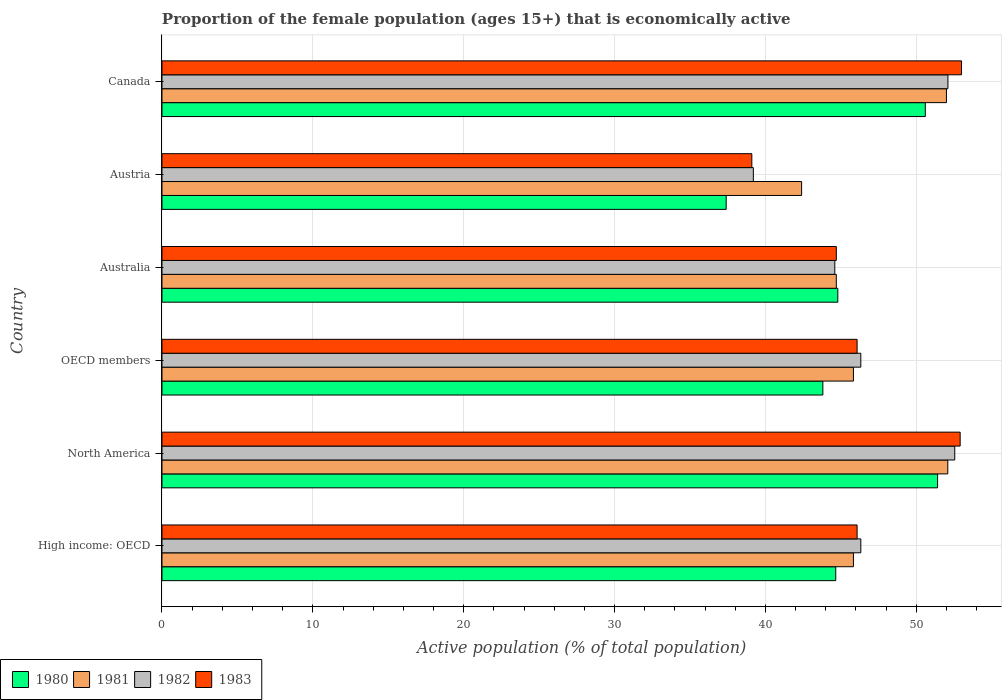How many different coloured bars are there?
Provide a succinct answer. 4. How many groups of bars are there?
Offer a very short reply. 6. Are the number of bars per tick equal to the number of legend labels?
Your response must be concise. Yes. How many bars are there on the 5th tick from the top?
Give a very brief answer. 4. In how many cases, is the number of bars for a given country not equal to the number of legend labels?
Keep it short and to the point. 0. What is the proportion of the female population that is economically active in 1981 in Austria?
Your response must be concise. 42.4. Across all countries, what is the maximum proportion of the female population that is economically active in 1980?
Make the answer very short. 51.41. Across all countries, what is the minimum proportion of the female population that is economically active in 1981?
Keep it short and to the point. 42.4. In which country was the proportion of the female population that is economically active in 1983 maximum?
Your answer should be very brief. Canada. In which country was the proportion of the female population that is economically active in 1981 minimum?
Provide a succinct answer. Austria. What is the total proportion of the female population that is economically active in 1980 in the graph?
Your response must be concise. 272.69. What is the difference between the proportion of the female population that is economically active in 1983 in High income: OECD and that in OECD members?
Keep it short and to the point. 0. What is the difference between the proportion of the female population that is economically active in 1980 in Australia and the proportion of the female population that is economically active in 1982 in High income: OECD?
Give a very brief answer. -1.52. What is the average proportion of the female population that is economically active in 1981 per country?
Provide a short and direct response. 47.14. What is the difference between the proportion of the female population that is economically active in 1983 and proportion of the female population that is economically active in 1981 in High income: OECD?
Provide a succinct answer. 0.24. In how many countries, is the proportion of the female population that is economically active in 1980 greater than 38 %?
Give a very brief answer. 5. What is the ratio of the proportion of the female population that is economically active in 1982 in High income: OECD to that in OECD members?
Keep it short and to the point. 1. Is the proportion of the female population that is economically active in 1983 in High income: OECD less than that in OECD members?
Give a very brief answer. No. What is the difference between the highest and the second highest proportion of the female population that is economically active in 1980?
Offer a very short reply. 0.81. What is the difference between the highest and the lowest proportion of the female population that is economically active in 1983?
Offer a very short reply. 13.9. In how many countries, is the proportion of the female population that is economically active in 1980 greater than the average proportion of the female population that is economically active in 1980 taken over all countries?
Keep it short and to the point. 2. Is the sum of the proportion of the female population that is economically active in 1983 in North America and OECD members greater than the maximum proportion of the female population that is economically active in 1982 across all countries?
Offer a very short reply. Yes. Is it the case that in every country, the sum of the proportion of the female population that is economically active in 1980 and proportion of the female population that is economically active in 1983 is greater than the sum of proportion of the female population that is economically active in 1981 and proportion of the female population that is economically active in 1982?
Your answer should be very brief. No. Is it the case that in every country, the sum of the proportion of the female population that is economically active in 1982 and proportion of the female population that is economically active in 1980 is greater than the proportion of the female population that is economically active in 1983?
Make the answer very short. Yes. Are all the bars in the graph horizontal?
Your answer should be compact. Yes. How many countries are there in the graph?
Ensure brevity in your answer.  6. What is the difference between two consecutive major ticks on the X-axis?
Your answer should be very brief. 10. Where does the legend appear in the graph?
Make the answer very short. Bottom left. How many legend labels are there?
Your answer should be compact. 4. What is the title of the graph?
Provide a succinct answer. Proportion of the female population (ages 15+) that is economically active. Does "2003" appear as one of the legend labels in the graph?
Ensure brevity in your answer.  No. What is the label or title of the X-axis?
Your response must be concise. Active population (% of total population). What is the Active population (% of total population) in 1980 in High income: OECD?
Provide a succinct answer. 44.66. What is the Active population (% of total population) of 1981 in High income: OECD?
Offer a very short reply. 45.84. What is the Active population (% of total population) in 1982 in High income: OECD?
Provide a short and direct response. 46.32. What is the Active population (% of total population) in 1983 in High income: OECD?
Keep it short and to the point. 46.08. What is the Active population (% of total population) in 1980 in North America?
Your answer should be compact. 51.41. What is the Active population (% of total population) in 1981 in North America?
Your answer should be compact. 52.09. What is the Active population (% of total population) in 1982 in North America?
Give a very brief answer. 52.55. What is the Active population (% of total population) of 1983 in North America?
Your answer should be very brief. 52.91. What is the Active population (% of total population) in 1980 in OECD members?
Your answer should be very brief. 43.81. What is the Active population (% of total population) in 1981 in OECD members?
Your answer should be very brief. 45.84. What is the Active population (% of total population) in 1982 in OECD members?
Provide a short and direct response. 46.32. What is the Active population (% of total population) of 1983 in OECD members?
Your response must be concise. 46.08. What is the Active population (% of total population) in 1980 in Australia?
Provide a succinct answer. 44.8. What is the Active population (% of total population) in 1981 in Australia?
Give a very brief answer. 44.7. What is the Active population (% of total population) in 1982 in Australia?
Your answer should be very brief. 44.6. What is the Active population (% of total population) in 1983 in Australia?
Your answer should be very brief. 44.7. What is the Active population (% of total population) in 1980 in Austria?
Your response must be concise. 37.4. What is the Active population (% of total population) of 1981 in Austria?
Ensure brevity in your answer.  42.4. What is the Active population (% of total population) in 1982 in Austria?
Make the answer very short. 39.2. What is the Active population (% of total population) in 1983 in Austria?
Your response must be concise. 39.1. What is the Active population (% of total population) of 1980 in Canada?
Give a very brief answer. 50.6. What is the Active population (% of total population) of 1982 in Canada?
Provide a short and direct response. 52.1. Across all countries, what is the maximum Active population (% of total population) in 1980?
Ensure brevity in your answer.  51.41. Across all countries, what is the maximum Active population (% of total population) of 1981?
Your response must be concise. 52.09. Across all countries, what is the maximum Active population (% of total population) of 1982?
Keep it short and to the point. 52.55. Across all countries, what is the minimum Active population (% of total population) in 1980?
Offer a very short reply. 37.4. Across all countries, what is the minimum Active population (% of total population) of 1981?
Make the answer very short. 42.4. Across all countries, what is the minimum Active population (% of total population) in 1982?
Your answer should be very brief. 39.2. Across all countries, what is the minimum Active population (% of total population) of 1983?
Provide a short and direct response. 39.1. What is the total Active population (% of total population) in 1980 in the graph?
Your response must be concise. 272.69. What is the total Active population (% of total population) of 1981 in the graph?
Provide a succinct answer. 282.86. What is the total Active population (% of total population) of 1982 in the graph?
Offer a very short reply. 281.1. What is the total Active population (% of total population) in 1983 in the graph?
Your response must be concise. 281.87. What is the difference between the Active population (% of total population) of 1980 in High income: OECD and that in North America?
Give a very brief answer. -6.75. What is the difference between the Active population (% of total population) of 1981 in High income: OECD and that in North America?
Your answer should be compact. -6.25. What is the difference between the Active population (% of total population) in 1982 in High income: OECD and that in North America?
Keep it short and to the point. -6.23. What is the difference between the Active population (% of total population) in 1983 in High income: OECD and that in North America?
Provide a succinct answer. -6.83. What is the difference between the Active population (% of total population) of 1980 in High income: OECD and that in OECD members?
Your answer should be compact. 0.85. What is the difference between the Active population (% of total population) in 1981 in High income: OECD and that in OECD members?
Your answer should be very brief. 0. What is the difference between the Active population (% of total population) in 1980 in High income: OECD and that in Australia?
Make the answer very short. -0.14. What is the difference between the Active population (% of total population) in 1981 in High income: OECD and that in Australia?
Offer a very short reply. 1.14. What is the difference between the Active population (% of total population) in 1982 in High income: OECD and that in Australia?
Make the answer very short. 1.72. What is the difference between the Active population (% of total population) of 1983 in High income: OECD and that in Australia?
Offer a terse response. 1.38. What is the difference between the Active population (% of total population) in 1980 in High income: OECD and that in Austria?
Provide a succinct answer. 7.26. What is the difference between the Active population (% of total population) of 1981 in High income: OECD and that in Austria?
Your answer should be very brief. 3.44. What is the difference between the Active population (% of total population) in 1982 in High income: OECD and that in Austria?
Keep it short and to the point. 7.12. What is the difference between the Active population (% of total population) in 1983 in High income: OECD and that in Austria?
Ensure brevity in your answer.  6.98. What is the difference between the Active population (% of total population) of 1980 in High income: OECD and that in Canada?
Offer a terse response. -5.94. What is the difference between the Active population (% of total population) of 1981 in High income: OECD and that in Canada?
Provide a succinct answer. -6.16. What is the difference between the Active population (% of total population) in 1982 in High income: OECD and that in Canada?
Make the answer very short. -5.78. What is the difference between the Active population (% of total population) in 1983 in High income: OECD and that in Canada?
Provide a short and direct response. -6.92. What is the difference between the Active population (% of total population) in 1980 in North America and that in OECD members?
Your answer should be very brief. 7.61. What is the difference between the Active population (% of total population) in 1981 in North America and that in OECD members?
Provide a succinct answer. 6.25. What is the difference between the Active population (% of total population) in 1982 in North America and that in OECD members?
Provide a short and direct response. 6.23. What is the difference between the Active population (% of total population) in 1983 in North America and that in OECD members?
Your answer should be compact. 6.83. What is the difference between the Active population (% of total population) of 1980 in North America and that in Australia?
Offer a very short reply. 6.61. What is the difference between the Active population (% of total population) in 1981 in North America and that in Australia?
Ensure brevity in your answer.  7.39. What is the difference between the Active population (% of total population) in 1982 in North America and that in Australia?
Make the answer very short. 7.95. What is the difference between the Active population (% of total population) of 1983 in North America and that in Australia?
Ensure brevity in your answer.  8.21. What is the difference between the Active population (% of total population) of 1980 in North America and that in Austria?
Offer a very short reply. 14.01. What is the difference between the Active population (% of total population) in 1981 in North America and that in Austria?
Offer a very short reply. 9.69. What is the difference between the Active population (% of total population) in 1982 in North America and that in Austria?
Make the answer very short. 13.35. What is the difference between the Active population (% of total population) of 1983 in North America and that in Austria?
Your answer should be very brief. 13.81. What is the difference between the Active population (% of total population) of 1980 in North America and that in Canada?
Keep it short and to the point. 0.81. What is the difference between the Active population (% of total population) in 1981 in North America and that in Canada?
Make the answer very short. 0.09. What is the difference between the Active population (% of total population) of 1982 in North America and that in Canada?
Make the answer very short. 0.45. What is the difference between the Active population (% of total population) of 1983 in North America and that in Canada?
Make the answer very short. -0.09. What is the difference between the Active population (% of total population) of 1980 in OECD members and that in Australia?
Offer a terse response. -0.99. What is the difference between the Active population (% of total population) of 1981 in OECD members and that in Australia?
Provide a short and direct response. 1.14. What is the difference between the Active population (% of total population) in 1982 in OECD members and that in Australia?
Provide a succinct answer. 1.72. What is the difference between the Active population (% of total population) in 1983 in OECD members and that in Australia?
Offer a very short reply. 1.38. What is the difference between the Active population (% of total population) of 1980 in OECD members and that in Austria?
Offer a terse response. 6.41. What is the difference between the Active population (% of total population) of 1981 in OECD members and that in Austria?
Offer a very short reply. 3.44. What is the difference between the Active population (% of total population) of 1982 in OECD members and that in Austria?
Your answer should be very brief. 7.12. What is the difference between the Active population (% of total population) in 1983 in OECD members and that in Austria?
Make the answer very short. 6.98. What is the difference between the Active population (% of total population) in 1980 in OECD members and that in Canada?
Provide a succinct answer. -6.79. What is the difference between the Active population (% of total population) in 1981 in OECD members and that in Canada?
Provide a short and direct response. -6.16. What is the difference between the Active population (% of total population) of 1982 in OECD members and that in Canada?
Your answer should be very brief. -5.78. What is the difference between the Active population (% of total population) in 1983 in OECD members and that in Canada?
Keep it short and to the point. -6.92. What is the difference between the Active population (% of total population) of 1980 in Australia and that in Canada?
Your answer should be very brief. -5.8. What is the difference between the Active population (% of total population) of 1981 in Australia and that in Canada?
Your response must be concise. -7.3. What is the difference between the Active population (% of total population) of 1982 in Australia and that in Canada?
Your response must be concise. -7.5. What is the difference between the Active population (% of total population) in 1983 in Australia and that in Canada?
Ensure brevity in your answer.  -8.3. What is the difference between the Active population (% of total population) of 1980 in Austria and that in Canada?
Provide a short and direct response. -13.2. What is the difference between the Active population (% of total population) of 1982 in Austria and that in Canada?
Offer a terse response. -12.9. What is the difference between the Active population (% of total population) of 1980 in High income: OECD and the Active population (% of total population) of 1981 in North America?
Offer a very short reply. -7.43. What is the difference between the Active population (% of total population) in 1980 in High income: OECD and the Active population (% of total population) in 1982 in North America?
Offer a terse response. -7.89. What is the difference between the Active population (% of total population) of 1980 in High income: OECD and the Active population (% of total population) of 1983 in North America?
Give a very brief answer. -8.25. What is the difference between the Active population (% of total population) of 1981 in High income: OECD and the Active population (% of total population) of 1982 in North America?
Offer a very short reply. -6.72. What is the difference between the Active population (% of total population) in 1981 in High income: OECD and the Active population (% of total population) in 1983 in North America?
Offer a terse response. -7.07. What is the difference between the Active population (% of total population) in 1982 in High income: OECD and the Active population (% of total population) in 1983 in North America?
Provide a succinct answer. -6.58. What is the difference between the Active population (% of total population) in 1980 in High income: OECD and the Active population (% of total population) in 1981 in OECD members?
Ensure brevity in your answer.  -1.17. What is the difference between the Active population (% of total population) in 1980 in High income: OECD and the Active population (% of total population) in 1982 in OECD members?
Provide a short and direct response. -1.66. What is the difference between the Active population (% of total population) in 1980 in High income: OECD and the Active population (% of total population) in 1983 in OECD members?
Your response must be concise. -1.42. What is the difference between the Active population (% of total population) in 1981 in High income: OECD and the Active population (% of total population) in 1982 in OECD members?
Ensure brevity in your answer.  -0.49. What is the difference between the Active population (% of total population) of 1981 in High income: OECD and the Active population (% of total population) of 1983 in OECD members?
Keep it short and to the point. -0.24. What is the difference between the Active population (% of total population) in 1982 in High income: OECD and the Active population (% of total population) in 1983 in OECD members?
Your answer should be very brief. 0.25. What is the difference between the Active population (% of total population) of 1980 in High income: OECD and the Active population (% of total population) of 1981 in Australia?
Your response must be concise. -0.04. What is the difference between the Active population (% of total population) of 1980 in High income: OECD and the Active population (% of total population) of 1982 in Australia?
Offer a very short reply. 0.06. What is the difference between the Active population (% of total population) of 1980 in High income: OECD and the Active population (% of total population) of 1983 in Australia?
Provide a short and direct response. -0.04. What is the difference between the Active population (% of total population) of 1981 in High income: OECD and the Active population (% of total population) of 1982 in Australia?
Give a very brief answer. 1.24. What is the difference between the Active population (% of total population) of 1981 in High income: OECD and the Active population (% of total population) of 1983 in Australia?
Ensure brevity in your answer.  1.14. What is the difference between the Active population (% of total population) in 1982 in High income: OECD and the Active population (% of total population) in 1983 in Australia?
Give a very brief answer. 1.62. What is the difference between the Active population (% of total population) in 1980 in High income: OECD and the Active population (% of total population) in 1981 in Austria?
Make the answer very short. 2.26. What is the difference between the Active population (% of total population) of 1980 in High income: OECD and the Active population (% of total population) of 1982 in Austria?
Offer a very short reply. 5.46. What is the difference between the Active population (% of total population) of 1980 in High income: OECD and the Active population (% of total population) of 1983 in Austria?
Make the answer very short. 5.56. What is the difference between the Active population (% of total population) in 1981 in High income: OECD and the Active population (% of total population) in 1982 in Austria?
Provide a succinct answer. 6.64. What is the difference between the Active population (% of total population) of 1981 in High income: OECD and the Active population (% of total population) of 1983 in Austria?
Ensure brevity in your answer.  6.74. What is the difference between the Active population (% of total population) in 1982 in High income: OECD and the Active population (% of total population) in 1983 in Austria?
Your response must be concise. 7.22. What is the difference between the Active population (% of total population) in 1980 in High income: OECD and the Active population (% of total population) in 1981 in Canada?
Your response must be concise. -7.34. What is the difference between the Active population (% of total population) of 1980 in High income: OECD and the Active population (% of total population) of 1982 in Canada?
Your answer should be very brief. -7.44. What is the difference between the Active population (% of total population) in 1980 in High income: OECD and the Active population (% of total population) in 1983 in Canada?
Provide a succinct answer. -8.34. What is the difference between the Active population (% of total population) in 1981 in High income: OECD and the Active population (% of total population) in 1982 in Canada?
Ensure brevity in your answer.  -6.26. What is the difference between the Active population (% of total population) in 1981 in High income: OECD and the Active population (% of total population) in 1983 in Canada?
Provide a succinct answer. -7.16. What is the difference between the Active population (% of total population) in 1982 in High income: OECD and the Active population (% of total population) in 1983 in Canada?
Give a very brief answer. -6.68. What is the difference between the Active population (% of total population) of 1980 in North America and the Active population (% of total population) of 1981 in OECD members?
Ensure brevity in your answer.  5.58. What is the difference between the Active population (% of total population) in 1980 in North America and the Active population (% of total population) in 1982 in OECD members?
Give a very brief answer. 5.09. What is the difference between the Active population (% of total population) in 1980 in North America and the Active population (% of total population) in 1983 in OECD members?
Your answer should be very brief. 5.34. What is the difference between the Active population (% of total population) of 1981 in North America and the Active population (% of total population) of 1982 in OECD members?
Offer a very short reply. 5.77. What is the difference between the Active population (% of total population) in 1981 in North America and the Active population (% of total population) in 1983 in OECD members?
Your response must be concise. 6.01. What is the difference between the Active population (% of total population) in 1982 in North America and the Active population (% of total population) in 1983 in OECD members?
Keep it short and to the point. 6.47. What is the difference between the Active population (% of total population) in 1980 in North America and the Active population (% of total population) in 1981 in Australia?
Your answer should be compact. 6.71. What is the difference between the Active population (% of total population) of 1980 in North America and the Active population (% of total population) of 1982 in Australia?
Offer a terse response. 6.81. What is the difference between the Active population (% of total population) in 1980 in North America and the Active population (% of total population) in 1983 in Australia?
Your answer should be compact. 6.71. What is the difference between the Active population (% of total population) of 1981 in North America and the Active population (% of total population) of 1982 in Australia?
Your response must be concise. 7.49. What is the difference between the Active population (% of total population) of 1981 in North America and the Active population (% of total population) of 1983 in Australia?
Offer a terse response. 7.39. What is the difference between the Active population (% of total population) in 1982 in North America and the Active population (% of total population) in 1983 in Australia?
Give a very brief answer. 7.85. What is the difference between the Active population (% of total population) in 1980 in North America and the Active population (% of total population) in 1981 in Austria?
Offer a very short reply. 9.01. What is the difference between the Active population (% of total population) of 1980 in North America and the Active population (% of total population) of 1982 in Austria?
Give a very brief answer. 12.21. What is the difference between the Active population (% of total population) in 1980 in North America and the Active population (% of total population) in 1983 in Austria?
Ensure brevity in your answer.  12.31. What is the difference between the Active population (% of total population) in 1981 in North America and the Active population (% of total population) in 1982 in Austria?
Provide a short and direct response. 12.89. What is the difference between the Active population (% of total population) of 1981 in North America and the Active population (% of total population) of 1983 in Austria?
Keep it short and to the point. 12.99. What is the difference between the Active population (% of total population) in 1982 in North America and the Active population (% of total population) in 1983 in Austria?
Provide a short and direct response. 13.45. What is the difference between the Active population (% of total population) of 1980 in North America and the Active population (% of total population) of 1981 in Canada?
Give a very brief answer. -0.59. What is the difference between the Active population (% of total population) of 1980 in North America and the Active population (% of total population) of 1982 in Canada?
Your response must be concise. -0.69. What is the difference between the Active population (% of total population) of 1980 in North America and the Active population (% of total population) of 1983 in Canada?
Your response must be concise. -1.59. What is the difference between the Active population (% of total population) of 1981 in North America and the Active population (% of total population) of 1982 in Canada?
Offer a very short reply. -0.01. What is the difference between the Active population (% of total population) in 1981 in North America and the Active population (% of total population) in 1983 in Canada?
Offer a terse response. -0.91. What is the difference between the Active population (% of total population) in 1982 in North America and the Active population (% of total population) in 1983 in Canada?
Your answer should be very brief. -0.45. What is the difference between the Active population (% of total population) of 1980 in OECD members and the Active population (% of total population) of 1981 in Australia?
Ensure brevity in your answer.  -0.89. What is the difference between the Active population (% of total population) in 1980 in OECD members and the Active population (% of total population) in 1982 in Australia?
Provide a succinct answer. -0.79. What is the difference between the Active population (% of total population) in 1980 in OECD members and the Active population (% of total population) in 1983 in Australia?
Give a very brief answer. -0.89. What is the difference between the Active population (% of total population) of 1981 in OECD members and the Active population (% of total population) of 1982 in Australia?
Provide a succinct answer. 1.24. What is the difference between the Active population (% of total population) in 1981 in OECD members and the Active population (% of total population) in 1983 in Australia?
Offer a terse response. 1.14. What is the difference between the Active population (% of total population) of 1982 in OECD members and the Active population (% of total population) of 1983 in Australia?
Your answer should be very brief. 1.62. What is the difference between the Active population (% of total population) in 1980 in OECD members and the Active population (% of total population) in 1981 in Austria?
Keep it short and to the point. 1.41. What is the difference between the Active population (% of total population) of 1980 in OECD members and the Active population (% of total population) of 1982 in Austria?
Ensure brevity in your answer.  4.61. What is the difference between the Active population (% of total population) in 1980 in OECD members and the Active population (% of total population) in 1983 in Austria?
Provide a short and direct response. 4.71. What is the difference between the Active population (% of total population) in 1981 in OECD members and the Active population (% of total population) in 1982 in Austria?
Your response must be concise. 6.64. What is the difference between the Active population (% of total population) in 1981 in OECD members and the Active population (% of total population) in 1983 in Austria?
Make the answer very short. 6.74. What is the difference between the Active population (% of total population) of 1982 in OECD members and the Active population (% of total population) of 1983 in Austria?
Your answer should be very brief. 7.22. What is the difference between the Active population (% of total population) in 1980 in OECD members and the Active population (% of total population) in 1981 in Canada?
Give a very brief answer. -8.19. What is the difference between the Active population (% of total population) in 1980 in OECD members and the Active population (% of total population) in 1982 in Canada?
Keep it short and to the point. -8.29. What is the difference between the Active population (% of total population) in 1980 in OECD members and the Active population (% of total population) in 1983 in Canada?
Your answer should be compact. -9.19. What is the difference between the Active population (% of total population) of 1981 in OECD members and the Active population (% of total population) of 1982 in Canada?
Your response must be concise. -6.26. What is the difference between the Active population (% of total population) in 1981 in OECD members and the Active population (% of total population) in 1983 in Canada?
Offer a terse response. -7.16. What is the difference between the Active population (% of total population) in 1982 in OECD members and the Active population (% of total population) in 1983 in Canada?
Give a very brief answer. -6.68. What is the difference between the Active population (% of total population) in 1980 in Australia and the Active population (% of total population) in 1983 in Austria?
Ensure brevity in your answer.  5.7. What is the difference between the Active population (% of total population) of 1981 in Australia and the Active population (% of total population) of 1983 in Austria?
Offer a terse response. 5.6. What is the difference between the Active population (% of total population) of 1982 in Australia and the Active population (% of total population) of 1983 in Austria?
Ensure brevity in your answer.  5.5. What is the difference between the Active population (% of total population) in 1981 in Australia and the Active population (% of total population) in 1982 in Canada?
Provide a succinct answer. -7.4. What is the difference between the Active population (% of total population) of 1981 in Australia and the Active population (% of total population) of 1983 in Canada?
Your response must be concise. -8.3. What is the difference between the Active population (% of total population) in 1982 in Australia and the Active population (% of total population) in 1983 in Canada?
Ensure brevity in your answer.  -8.4. What is the difference between the Active population (% of total population) in 1980 in Austria and the Active population (% of total population) in 1981 in Canada?
Offer a terse response. -14.6. What is the difference between the Active population (% of total population) of 1980 in Austria and the Active population (% of total population) of 1982 in Canada?
Give a very brief answer. -14.7. What is the difference between the Active population (% of total population) in 1980 in Austria and the Active population (% of total population) in 1983 in Canada?
Make the answer very short. -15.6. What is the difference between the Active population (% of total population) in 1981 in Austria and the Active population (% of total population) in 1982 in Canada?
Provide a succinct answer. -9.7. What is the difference between the Active population (% of total population) of 1981 in Austria and the Active population (% of total population) of 1983 in Canada?
Make the answer very short. -10.6. What is the average Active population (% of total population) in 1980 per country?
Give a very brief answer. 45.45. What is the average Active population (% of total population) in 1981 per country?
Provide a short and direct response. 47.14. What is the average Active population (% of total population) in 1982 per country?
Your response must be concise. 46.85. What is the average Active population (% of total population) of 1983 per country?
Keep it short and to the point. 46.98. What is the difference between the Active population (% of total population) of 1980 and Active population (% of total population) of 1981 in High income: OECD?
Your answer should be compact. -1.17. What is the difference between the Active population (% of total population) in 1980 and Active population (% of total population) in 1982 in High income: OECD?
Provide a succinct answer. -1.66. What is the difference between the Active population (% of total population) in 1980 and Active population (% of total population) in 1983 in High income: OECD?
Offer a terse response. -1.42. What is the difference between the Active population (% of total population) in 1981 and Active population (% of total population) in 1982 in High income: OECD?
Provide a succinct answer. -0.49. What is the difference between the Active population (% of total population) in 1981 and Active population (% of total population) in 1983 in High income: OECD?
Give a very brief answer. -0.24. What is the difference between the Active population (% of total population) of 1982 and Active population (% of total population) of 1983 in High income: OECD?
Ensure brevity in your answer.  0.25. What is the difference between the Active population (% of total population) of 1980 and Active population (% of total population) of 1981 in North America?
Your answer should be very brief. -0.68. What is the difference between the Active population (% of total population) of 1980 and Active population (% of total population) of 1982 in North America?
Your response must be concise. -1.14. What is the difference between the Active population (% of total population) of 1980 and Active population (% of total population) of 1983 in North America?
Your answer should be very brief. -1.5. What is the difference between the Active population (% of total population) of 1981 and Active population (% of total population) of 1982 in North America?
Your answer should be compact. -0.46. What is the difference between the Active population (% of total population) of 1981 and Active population (% of total population) of 1983 in North America?
Offer a terse response. -0.82. What is the difference between the Active population (% of total population) of 1982 and Active population (% of total population) of 1983 in North America?
Your answer should be very brief. -0.36. What is the difference between the Active population (% of total population) in 1980 and Active population (% of total population) in 1981 in OECD members?
Ensure brevity in your answer.  -2.03. What is the difference between the Active population (% of total population) of 1980 and Active population (% of total population) of 1982 in OECD members?
Offer a very short reply. -2.52. What is the difference between the Active population (% of total population) of 1980 and Active population (% of total population) of 1983 in OECD members?
Give a very brief answer. -2.27. What is the difference between the Active population (% of total population) of 1981 and Active population (% of total population) of 1982 in OECD members?
Provide a short and direct response. -0.49. What is the difference between the Active population (% of total population) in 1981 and Active population (% of total population) in 1983 in OECD members?
Give a very brief answer. -0.24. What is the difference between the Active population (% of total population) of 1982 and Active population (% of total population) of 1983 in OECD members?
Make the answer very short. 0.25. What is the difference between the Active population (% of total population) in 1980 and Active population (% of total population) in 1983 in Australia?
Offer a terse response. 0.1. What is the difference between the Active population (% of total population) of 1981 and Active population (% of total population) of 1982 in Australia?
Make the answer very short. 0.1. What is the difference between the Active population (% of total population) in 1980 and Active population (% of total population) in 1981 in Austria?
Offer a very short reply. -5. What is the difference between the Active population (% of total population) of 1980 and Active population (% of total population) of 1982 in Austria?
Provide a succinct answer. -1.8. What is the difference between the Active population (% of total population) in 1980 and Active population (% of total population) in 1983 in Austria?
Your answer should be compact. -1.7. What is the difference between the Active population (% of total population) of 1981 and Active population (% of total population) of 1983 in Austria?
Provide a short and direct response. 3.3. What is the difference between the Active population (% of total population) of 1982 and Active population (% of total population) of 1983 in Austria?
Ensure brevity in your answer.  0.1. What is the difference between the Active population (% of total population) in 1980 and Active population (% of total population) in 1983 in Canada?
Provide a succinct answer. -2.4. What is the difference between the Active population (% of total population) of 1981 and Active population (% of total population) of 1982 in Canada?
Provide a succinct answer. -0.1. What is the difference between the Active population (% of total population) in 1981 and Active population (% of total population) in 1983 in Canada?
Give a very brief answer. -1. What is the ratio of the Active population (% of total population) in 1980 in High income: OECD to that in North America?
Offer a terse response. 0.87. What is the ratio of the Active population (% of total population) in 1981 in High income: OECD to that in North America?
Make the answer very short. 0.88. What is the ratio of the Active population (% of total population) of 1982 in High income: OECD to that in North America?
Give a very brief answer. 0.88. What is the ratio of the Active population (% of total population) of 1983 in High income: OECD to that in North America?
Your answer should be very brief. 0.87. What is the ratio of the Active population (% of total population) in 1980 in High income: OECD to that in OECD members?
Offer a very short reply. 1.02. What is the ratio of the Active population (% of total population) in 1981 in High income: OECD to that in OECD members?
Offer a very short reply. 1. What is the ratio of the Active population (% of total population) in 1982 in High income: OECD to that in OECD members?
Provide a succinct answer. 1. What is the ratio of the Active population (% of total population) in 1981 in High income: OECD to that in Australia?
Offer a terse response. 1.03. What is the ratio of the Active population (% of total population) in 1982 in High income: OECD to that in Australia?
Provide a short and direct response. 1.04. What is the ratio of the Active population (% of total population) of 1983 in High income: OECD to that in Australia?
Your answer should be very brief. 1.03. What is the ratio of the Active population (% of total population) of 1980 in High income: OECD to that in Austria?
Give a very brief answer. 1.19. What is the ratio of the Active population (% of total population) in 1981 in High income: OECD to that in Austria?
Offer a very short reply. 1.08. What is the ratio of the Active population (% of total population) in 1982 in High income: OECD to that in Austria?
Make the answer very short. 1.18. What is the ratio of the Active population (% of total population) of 1983 in High income: OECD to that in Austria?
Provide a succinct answer. 1.18. What is the ratio of the Active population (% of total population) in 1980 in High income: OECD to that in Canada?
Your answer should be compact. 0.88. What is the ratio of the Active population (% of total population) in 1981 in High income: OECD to that in Canada?
Your answer should be very brief. 0.88. What is the ratio of the Active population (% of total population) in 1982 in High income: OECD to that in Canada?
Ensure brevity in your answer.  0.89. What is the ratio of the Active population (% of total population) in 1983 in High income: OECD to that in Canada?
Your answer should be compact. 0.87. What is the ratio of the Active population (% of total population) of 1980 in North America to that in OECD members?
Your answer should be very brief. 1.17. What is the ratio of the Active population (% of total population) of 1981 in North America to that in OECD members?
Provide a short and direct response. 1.14. What is the ratio of the Active population (% of total population) in 1982 in North America to that in OECD members?
Make the answer very short. 1.13. What is the ratio of the Active population (% of total population) in 1983 in North America to that in OECD members?
Provide a short and direct response. 1.15. What is the ratio of the Active population (% of total population) in 1980 in North America to that in Australia?
Provide a succinct answer. 1.15. What is the ratio of the Active population (% of total population) of 1981 in North America to that in Australia?
Your response must be concise. 1.17. What is the ratio of the Active population (% of total population) in 1982 in North America to that in Australia?
Offer a terse response. 1.18. What is the ratio of the Active population (% of total population) in 1983 in North America to that in Australia?
Make the answer very short. 1.18. What is the ratio of the Active population (% of total population) of 1980 in North America to that in Austria?
Your response must be concise. 1.37. What is the ratio of the Active population (% of total population) in 1981 in North America to that in Austria?
Give a very brief answer. 1.23. What is the ratio of the Active population (% of total population) of 1982 in North America to that in Austria?
Offer a terse response. 1.34. What is the ratio of the Active population (% of total population) in 1983 in North America to that in Austria?
Your response must be concise. 1.35. What is the ratio of the Active population (% of total population) of 1980 in North America to that in Canada?
Provide a short and direct response. 1.02. What is the ratio of the Active population (% of total population) of 1982 in North America to that in Canada?
Ensure brevity in your answer.  1.01. What is the ratio of the Active population (% of total population) of 1980 in OECD members to that in Australia?
Keep it short and to the point. 0.98. What is the ratio of the Active population (% of total population) in 1981 in OECD members to that in Australia?
Provide a succinct answer. 1.03. What is the ratio of the Active population (% of total population) in 1982 in OECD members to that in Australia?
Your response must be concise. 1.04. What is the ratio of the Active population (% of total population) of 1983 in OECD members to that in Australia?
Provide a short and direct response. 1.03. What is the ratio of the Active population (% of total population) of 1980 in OECD members to that in Austria?
Keep it short and to the point. 1.17. What is the ratio of the Active population (% of total population) of 1981 in OECD members to that in Austria?
Your answer should be very brief. 1.08. What is the ratio of the Active population (% of total population) of 1982 in OECD members to that in Austria?
Your answer should be very brief. 1.18. What is the ratio of the Active population (% of total population) in 1983 in OECD members to that in Austria?
Offer a very short reply. 1.18. What is the ratio of the Active population (% of total population) in 1980 in OECD members to that in Canada?
Your answer should be compact. 0.87. What is the ratio of the Active population (% of total population) in 1981 in OECD members to that in Canada?
Provide a succinct answer. 0.88. What is the ratio of the Active population (% of total population) in 1982 in OECD members to that in Canada?
Keep it short and to the point. 0.89. What is the ratio of the Active population (% of total population) in 1983 in OECD members to that in Canada?
Offer a very short reply. 0.87. What is the ratio of the Active population (% of total population) in 1980 in Australia to that in Austria?
Your response must be concise. 1.2. What is the ratio of the Active population (% of total population) in 1981 in Australia to that in Austria?
Offer a terse response. 1.05. What is the ratio of the Active population (% of total population) in 1982 in Australia to that in Austria?
Offer a very short reply. 1.14. What is the ratio of the Active population (% of total population) in 1983 in Australia to that in Austria?
Provide a succinct answer. 1.14. What is the ratio of the Active population (% of total population) of 1980 in Australia to that in Canada?
Provide a succinct answer. 0.89. What is the ratio of the Active population (% of total population) of 1981 in Australia to that in Canada?
Make the answer very short. 0.86. What is the ratio of the Active population (% of total population) of 1982 in Australia to that in Canada?
Provide a succinct answer. 0.86. What is the ratio of the Active population (% of total population) in 1983 in Australia to that in Canada?
Your response must be concise. 0.84. What is the ratio of the Active population (% of total population) in 1980 in Austria to that in Canada?
Make the answer very short. 0.74. What is the ratio of the Active population (% of total population) in 1981 in Austria to that in Canada?
Keep it short and to the point. 0.82. What is the ratio of the Active population (% of total population) in 1982 in Austria to that in Canada?
Make the answer very short. 0.75. What is the ratio of the Active population (% of total population) of 1983 in Austria to that in Canada?
Make the answer very short. 0.74. What is the difference between the highest and the second highest Active population (% of total population) of 1980?
Provide a succinct answer. 0.81. What is the difference between the highest and the second highest Active population (% of total population) of 1981?
Offer a terse response. 0.09. What is the difference between the highest and the second highest Active population (% of total population) in 1982?
Ensure brevity in your answer.  0.45. What is the difference between the highest and the second highest Active population (% of total population) of 1983?
Offer a very short reply. 0.09. What is the difference between the highest and the lowest Active population (% of total population) in 1980?
Provide a succinct answer. 14.01. What is the difference between the highest and the lowest Active population (% of total population) in 1981?
Provide a succinct answer. 9.69. What is the difference between the highest and the lowest Active population (% of total population) of 1982?
Provide a succinct answer. 13.35. What is the difference between the highest and the lowest Active population (% of total population) in 1983?
Give a very brief answer. 13.9. 